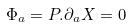Convert formula to latex. <formula><loc_0><loc_0><loc_500><loc_500>\Phi _ { a } = P . \partial _ { a } X = 0</formula> 